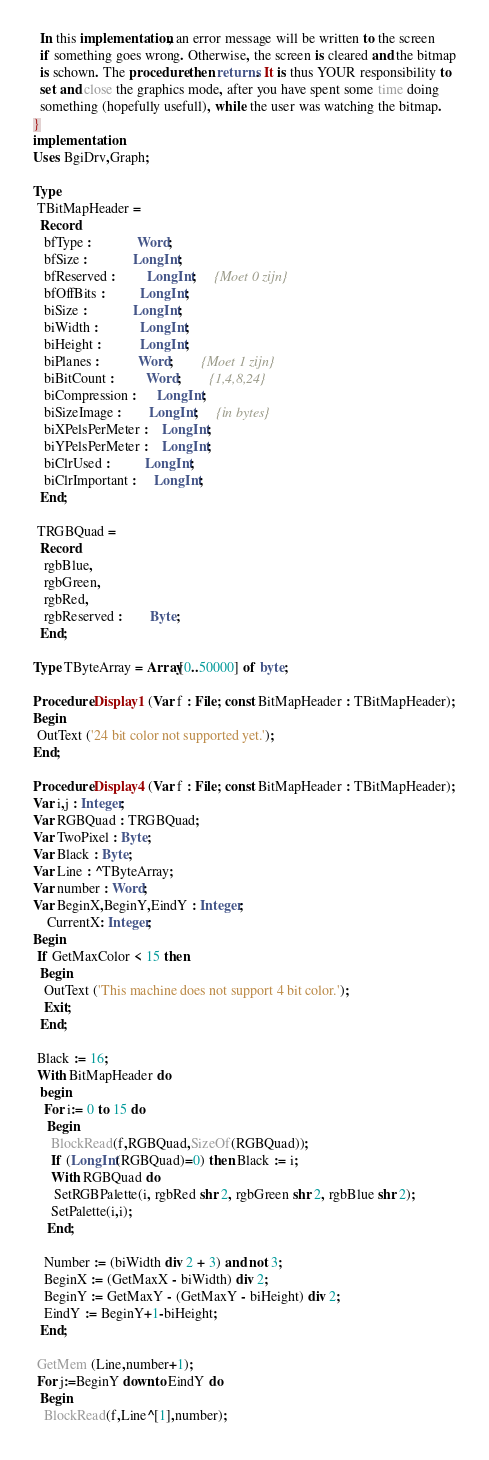<code> <loc_0><loc_0><loc_500><loc_500><_Pascal_>  In this implementation, an error message will be written to the screen
  if something goes wrong. Otherwise, the screen is cleared and the bitmap
  is schown. The procedure then returns. It is thus YOUR responsibility to
  set and close the graphics mode, after you have spent some time doing
  something (hopefully usefull), while the user was watching the bitmap.
}
implementation
Uses BgiDrv,Graph;

Type
 TBitMapHeader =
  Record
   bfType :             Word;
   bfSize :             LongInt;
   bfReserved :         LongInt;     {Moet 0 zijn}
   bfOffBits :          LongInt;
   biSize :             LongInt;
   biWidth :            LongInt;
   biHeight :           LongInt;
   biPlanes :           Word;        {Moet 1 zijn}
   biBitCount :         Word;        {1,4,8,24}
   biCompression :      LongInt;
   biSizeImage :        LongInt;     {in bytes}
   biXPelsPerMeter :    LongInt;
   biYPelsPerMeter :    LongInt;
   biClrUsed :          LongInt;
   biClrImportant :     LongInt;
  End;

 TRGBQuad =
  Record
   rgbBlue,
   rgbGreen,
   rgbRed,
   rgbReserved :        Byte;
  End;

Type TByteArray = Array[0..50000] of byte;

Procedure Display1 (Var f : File; const BitMapHeader : TBitMapHeader);
Begin
 OutText ('24 bit color not supported yet.');
End;

Procedure Display4 (Var f : File; const BitMapHeader : TBitMapHeader);
Var i,j : Integer;
Var RGBQuad : TRGBQuad;
Var TwoPixel : Byte;
Var Black : Byte;
Var Line : ^TByteArray;
Var number : Word;
Var BeginX,BeginY,EindY : Integer;
    CurrentX: Integer;
Begin
 If GetMaxColor < 15 then
  Begin
   OutText ('This machine does not support 4 bit color.');
   Exit;
  End;

 Black := 16;
 With BitMapHeader do
  begin
   For i:= 0 to 15 do
    Begin
     BlockRead(f,RGBQuad,SizeOf(RGBQuad));
     If (LongInt(RGBQuad)=0) then Black := i;
     With RGBQuad do
      SetRGBPalette(i, rgbRed shr 2, rgbGreen shr 2, rgbBlue shr 2);
     SetPalette(i,i);
    End;

   Number := (biWidth div 2 + 3) and not 3;
   BeginX := (GetMaxX - biWidth) div 2;
   BeginY := GetMaxY - (GetMaxY - biHeight) div 2;
   EindY := BeginY+1-biHeight;
  End;

 GetMem (Line,number+1);
 For j:=BeginY downto EindY do
  Begin
   BlockRead(f,Line^[1],number);</code> 